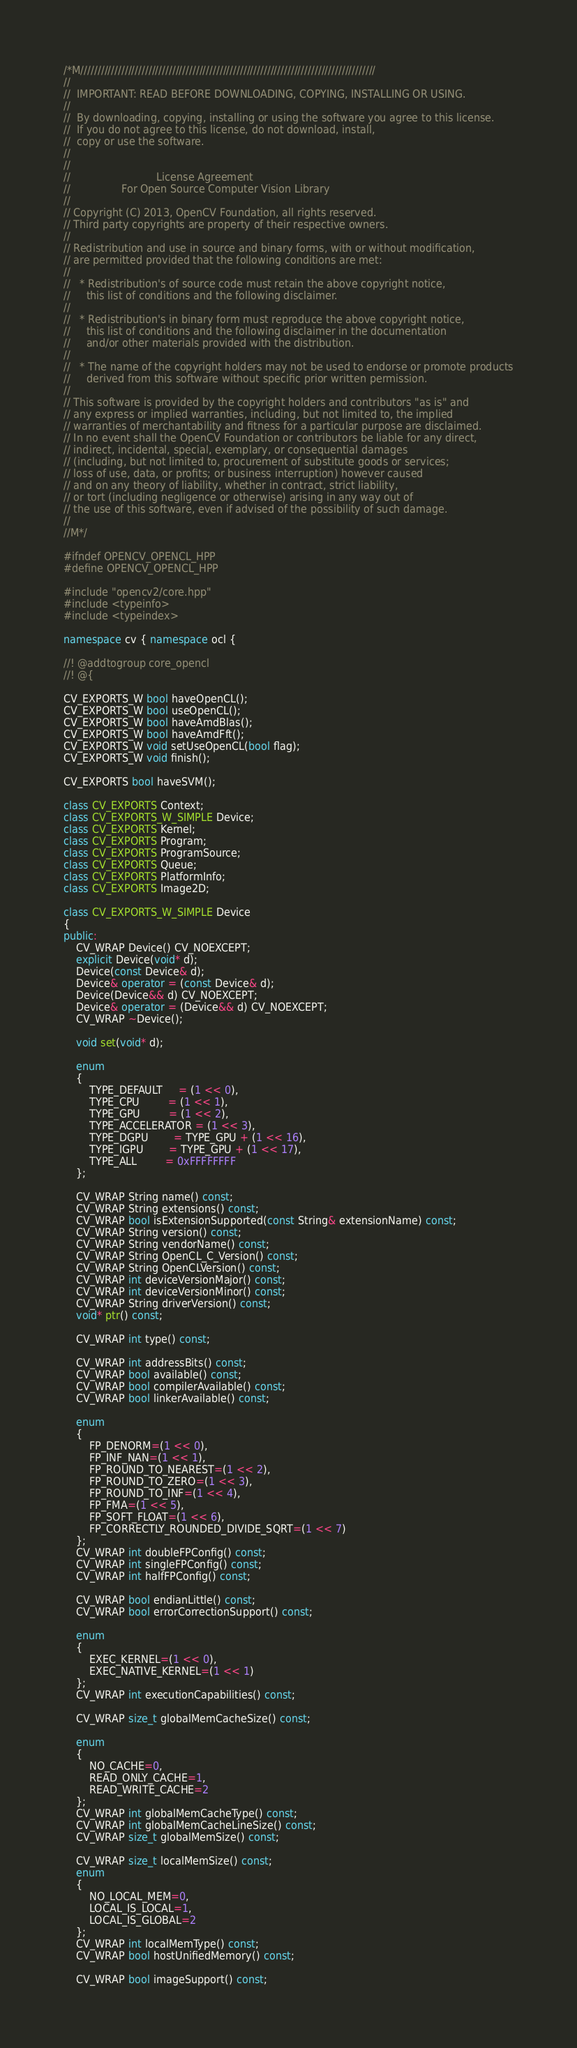Convert code to text. <code><loc_0><loc_0><loc_500><loc_500><_C++_>/*M///////////////////////////////////////////////////////////////////////////////////////
//
//  IMPORTANT: READ BEFORE DOWNLOADING, COPYING, INSTALLING OR USING.
//
//  By downloading, copying, installing or using the software you agree to this license.
//  If you do not agree to this license, do not download, install,
//  copy or use the software.
//
//
//                           License Agreement
//                For Open Source Computer Vision Library
//
// Copyright (C) 2013, OpenCV Foundation, all rights reserved.
// Third party copyrights are property of their respective owners.
//
// Redistribution and use in source and binary forms, with or without modification,
// are permitted provided that the following conditions are met:
//
//   * Redistribution's of source code must retain the above copyright notice,
//     this list of conditions and the following disclaimer.
//
//   * Redistribution's in binary form must reproduce the above copyright notice,
//     this list of conditions and the following disclaimer in the documentation
//     and/or other materials provided with the distribution.
//
//   * The name of the copyright holders may not be used to endorse or promote products
//     derived from this software without specific prior written permission.
//
// This software is provided by the copyright holders and contributors "as is" and
// any express or implied warranties, including, but not limited to, the implied
// warranties of merchantability and fitness for a particular purpose are disclaimed.
// In no event shall the OpenCV Foundation or contributors be liable for any direct,
// indirect, incidental, special, exemplary, or consequential damages
// (including, but not limited to, procurement of substitute goods or services;
// loss of use, data, or profits; or business interruption) however caused
// and on any theory of liability, whether in contract, strict liability,
// or tort (including negligence or otherwise) arising in any way out of
// the use of this software, even if advised of the possibility of such damage.
//
//M*/

#ifndef OPENCV_OPENCL_HPP
#define OPENCV_OPENCL_HPP

#include "opencv2/core.hpp"
#include <typeinfo>
#include <typeindex>

namespace cv { namespace ocl {

//! @addtogroup core_opencl
//! @{

CV_EXPORTS_W bool haveOpenCL();
CV_EXPORTS_W bool useOpenCL();
CV_EXPORTS_W bool haveAmdBlas();
CV_EXPORTS_W bool haveAmdFft();
CV_EXPORTS_W void setUseOpenCL(bool flag);
CV_EXPORTS_W void finish();

CV_EXPORTS bool haveSVM();

class CV_EXPORTS Context;
class CV_EXPORTS_W_SIMPLE Device;
class CV_EXPORTS Kernel;
class CV_EXPORTS Program;
class CV_EXPORTS ProgramSource;
class CV_EXPORTS Queue;
class CV_EXPORTS PlatformInfo;
class CV_EXPORTS Image2D;

class CV_EXPORTS_W_SIMPLE Device
{
public:
    CV_WRAP Device() CV_NOEXCEPT;
    explicit Device(void* d);
    Device(const Device& d);
    Device& operator = (const Device& d);
    Device(Device&& d) CV_NOEXCEPT;
    Device& operator = (Device&& d) CV_NOEXCEPT;
    CV_WRAP ~Device();

    void set(void* d);

    enum
    {
        TYPE_DEFAULT     = (1 << 0),
        TYPE_CPU         = (1 << 1),
        TYPE_GPU         = (1 << 2),
        TYPE_ACCELERATOR = (1 << 3),
        TYPE_DGPU        = TYPE_GPU + (1 << 16),
        TYPE_IGPU        = TYPE_GPU + (1 << 17),
        TYPE_ALL         = 0xFFFFFFFF
    };

    CV_WRAP String name() const;
    CV_WRAP String extensions() const;
    CV_WRAP bool isExtensionSupported(const String& extensionName) const;
    CV_WRAP String version() const;
    CV_WRAP String vendorName() const;
    CV_WRAP String OpenCL_C_Version() const;
    CV_WRAP String OpenCLVersion() const;
    CV_WRAP int deviceVersionMajor() const;
    CV_WRAP int deviceVersionMinor() const;
    CV_WRAP String driverVersion() const;
    void* ptr() const;

    CV_WRAP int type() const;

    CV_WRAP int addressBits() const;
    CV_WRAP bool available() const;
    CV_WRAP bool compilerAvailable() const;
    CV_WRAP bool linkerAvailable() const;

    enum
    {
        FP_DENORM=(1 << 0),
        FP_INF_NAN=(1 << 1),
        FP_ROUND_TO_NEAREST=(1 << 2),
        FP_ROUND_TO_ZERO=(1 << 3),
        FP_ROUND_TO_INF=(1 << 4),
        FP_FMA=(1 << 5),
        FP_SOFT_FLOAT=(1 << 6),
        FP_CORRECTLY_ROUNDED_DIVIDE_SQRT=(1 << 7)
    };
    CV_WRAP int doubleFPConfig() const;
    CV_WRAP int singleFPConfig() const;
    CV_WRAP int halfFPConfig() const;

    CV_WRAP bool endianLittle() const;
    CV_WRAP bool errorCorrectionSupport() const;

    enum
    {
        EXEC_KERNEL=(1 << 0),
        EXEC_NATIVE_KERNEL=(1 << 1)
    };
    CV_WRAP int executionCapabilities() const;

    CV_WRAP size_t globalMemCacheSize() const;

    enum
    {
        NO_CACHE=0,
        READ_ONLY_CACHE=1,
        READ_WRITE_CACHE=2
    };
    CV_WRAP int globalMemCacheType() const;
    CV_WRAP int globalMemCacheLineSize() const;
    CV_WRAP size_t globalMemSize() const;

    CV_WRAP size_t localMemSize() const;
    enum
    {
        NO_LOCAL_MEM=0,
        LOCAL_IS_LOCAL=1,
        LOCAL_IS_GLOBAL=2
    };
    CV_WRAP int localMemType() const;
    CV_WRAP bool hostUnifiedMemory() const;

    CV_WRAP bool imageSupport() const;
</code> 